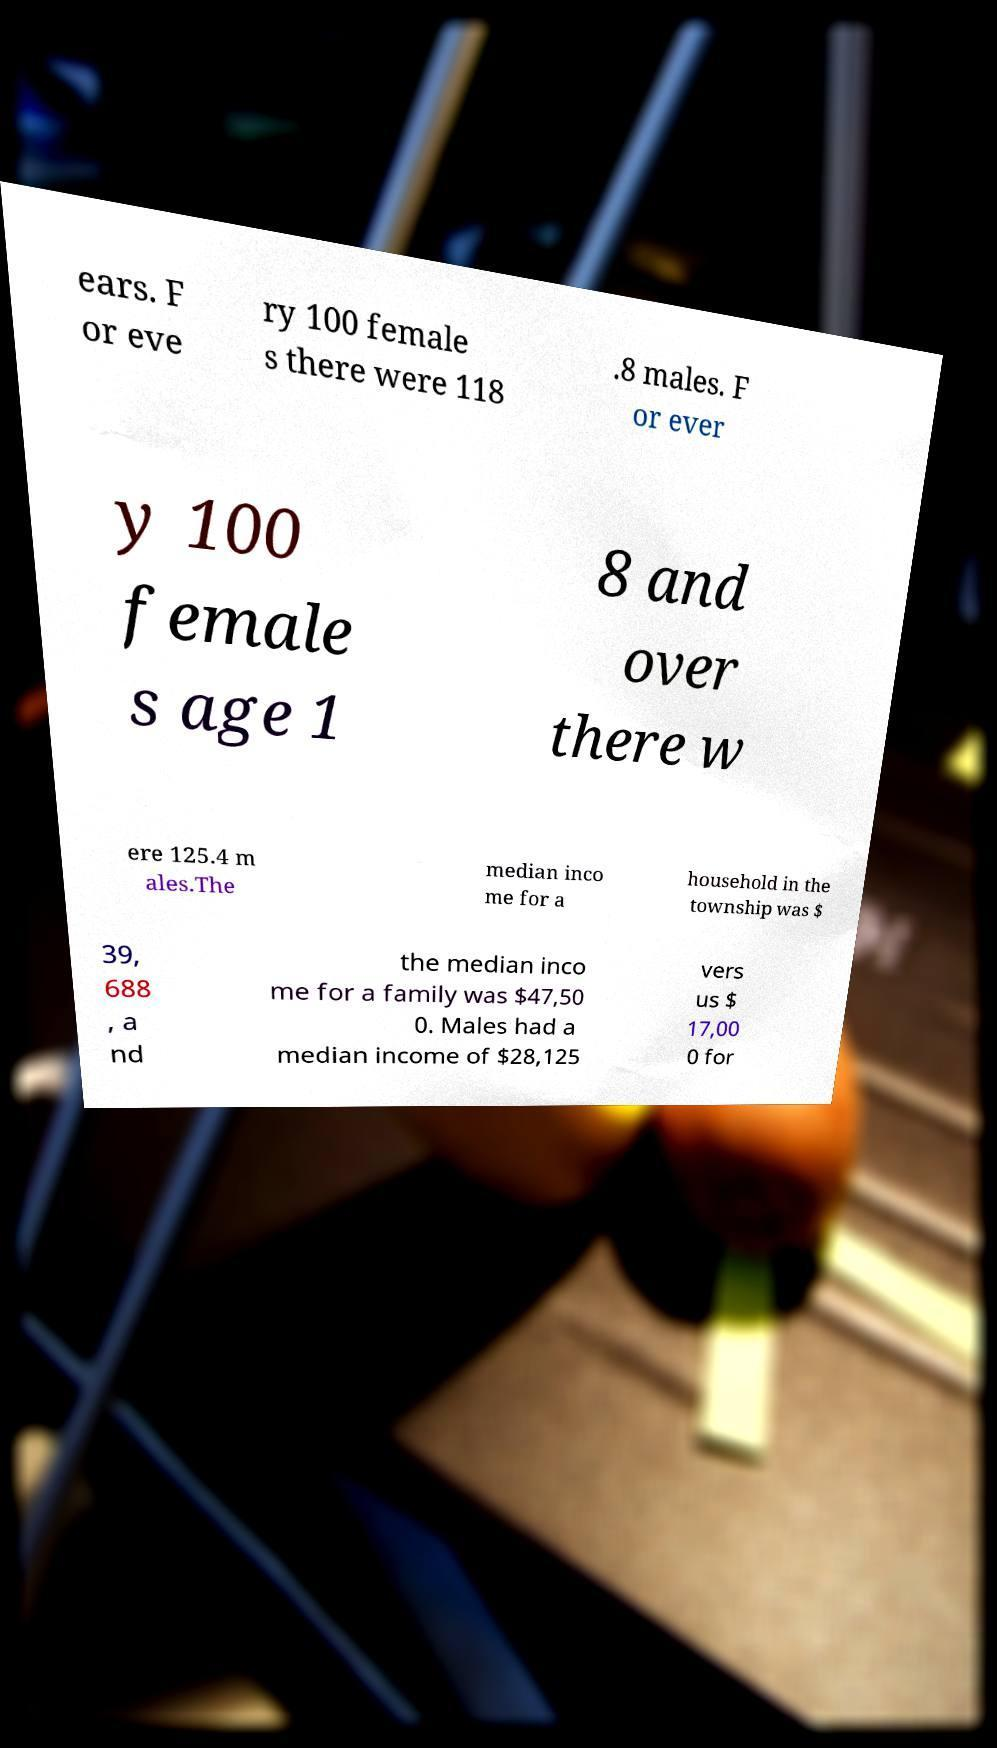For documentation purposes, I need the text within this image transcribed. Could you provide that? ears. F or eve ry 100 female s there were 118 .8 males. F or ever y 100 female s age 1 8 and over there w ere 125.4 m ales.The median inco me for a household in the township was $ 39, 688 , a nd the median inco me for a family was $47,50 0. Males had a median income of $28,125 vers us $ 17,00 0 for 